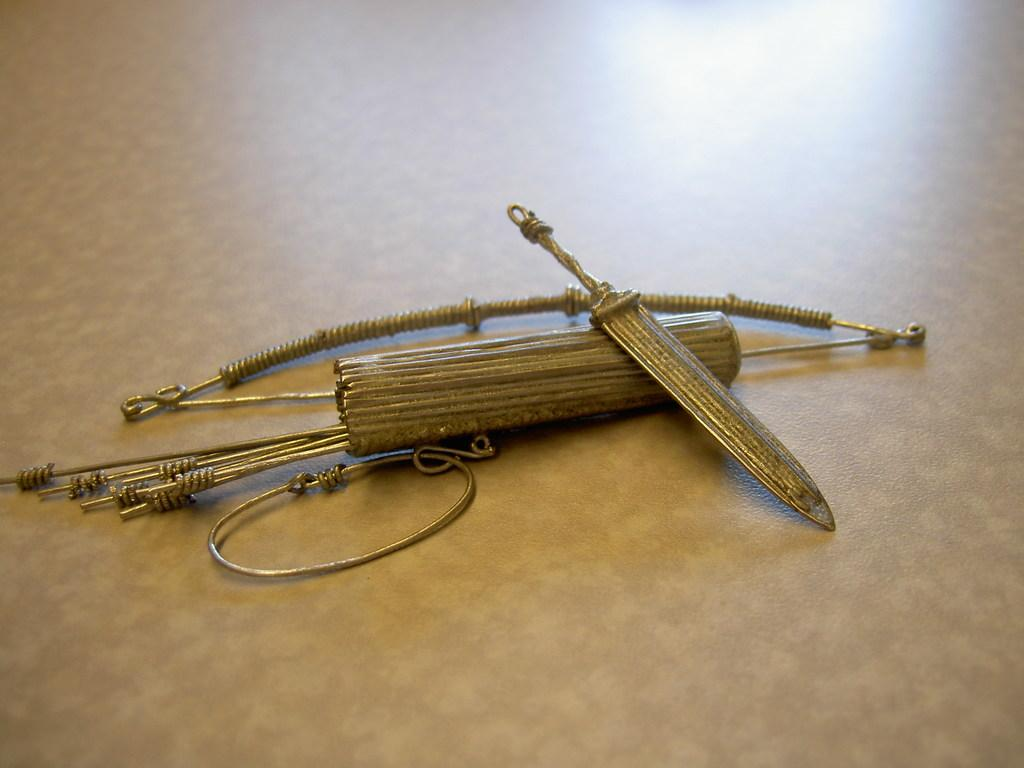What type of weapon is depicted in the image? There is an artificial bow and arrows in the image. What other weapon can be seen in the image? There is also a sword in the image. Where are all the objects located in the image? All objects are on the floor. How many dimes are scattered around the sword in the image? There are no dimes present in the image. What type of toys can be seen playing with the sword in the image? There are no toys present in the image. 